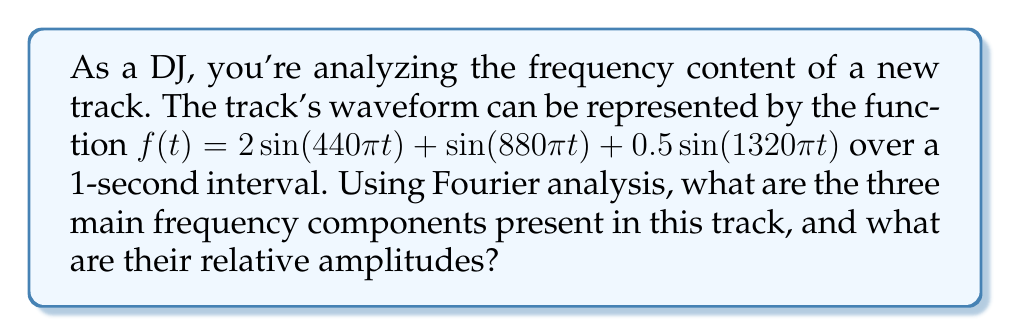Can you solve this math problem? To analyze the frequency spectrum of this audio waveform using Fourier analysis, we'll follow these steps:

1) The given function $f(t)$ is already expressed as a sum of sinusoids, which is the essence of Fourier analysis. Each sinusoid represents a frequency component.

2) For a sinusoid of the form $A\sin(2\pi ft)$:
   - $A$ is the amplitude
   - $f$ is the frequency in Hz

3) Let's analyze each term:

   a) $2\sin(440\pi t)$
      - Amplitude: $A_1 = 2$
      - Frequency: $440\pi = 2\pi f_1$, so $f_1 = 220$ Hz

   b) $\sin(880\pi t)$
      - Amplitude: $A_2 = 1$
      - Frequency: $880\pi = 2\pi f_2$, so $f_2 = 440$ Hz

   c) $0.5\sin(1320\pi t)$
      - Amplitude: $A_3 = 0.5$
      - Frequency: $1320\pi = 2\pi f_3$, so $f_3 = 660$ Hz

4) The relative amplitudes are proportional to the coefficients:
   2 : 1 : 0.5, which can be normalized to 4 : 2 : 1

Therefore, the three main frequency components are 220 Hz, 440 Hz, and 660 Hz, with relative amplitudes of 4, 2, and 1 respectively.
Answer: 220 Hz, 440 Hz, 660 Hz; 4:2:1 